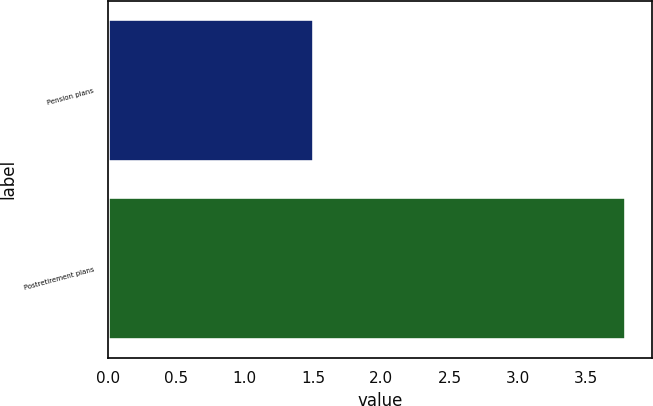Convert chart. <chart><loc_0><loc_0><loc_500><loc_500><bar_chart><fcel>Pension plans<fcel>Postretirement plans<nl><fcel>1.51<fcel>3.79<nl></chart> 